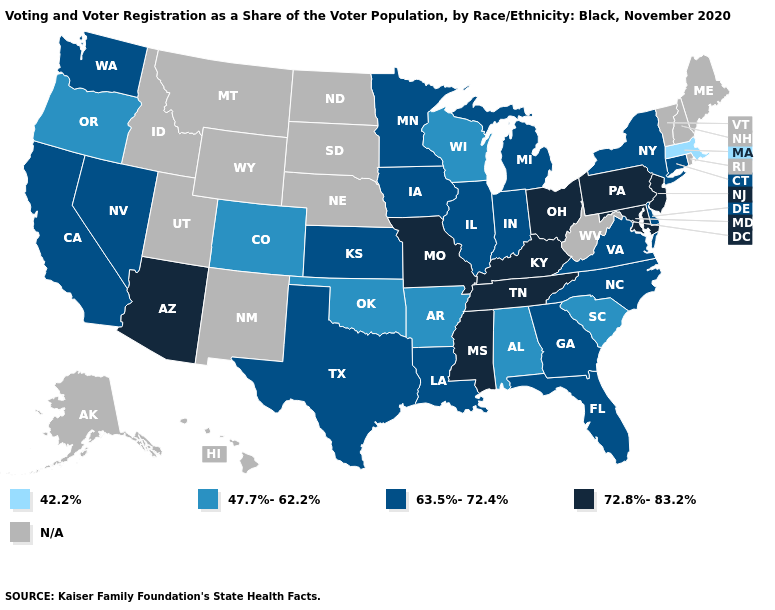What is the highest value in the USA?
Short answer required. 72.8%-83.2%. What is the value of Kansas?
Short answer required. 63.5%-72.4%. Which states hav the highest value in the West?
Keep it brief. Arizona. Does Florida have the highest value in the USA?
Write a very short answer. No. Name the states that have a value in the range 47.7%-62.2%?
Answer briefly. Alabama, Arkansas, Colorado, Oklahoma, Oregon, South Carolina, Wisconsin. What is the highest value in states that border North Dakota?
Write a very short answer. 63.5%-72.4%. What is the lowest value in the USA?
Answer briefly. 42.2%. What is the value of Wisconsin?
Keep it brief. 47.7%-62.2%. Name the states that have a value in the range 72.8%-83.2%?
Keep it brief. Arizona, Kentucky, Maryland, Mississippi, Missouri, New Jersey, Ohio, Pennsylvania, Tennessee. Name the states that have a value in the range N/A?
Write a very short answer. Alaska, Hawaii, Idaho, Maine, Montana, Nebraska, New Hampshire, New Mexico, North Dakota, Rhode Island, South Dakota, Utah, Vermont, West Virginia, Wyoming. Name the states that have a value in the range 42.2%?
Answer briefly. Massachusetts. What is the value of Indiana?
Concise answer only. 63.5%-72.4%. Among the states that border Massachusetts , which have the lowest value?
Quick response, please. Connecticut, New York. Among the states that border Indiana , which have the lowest value?
Write a very short answer. Illinois, Michigan. 